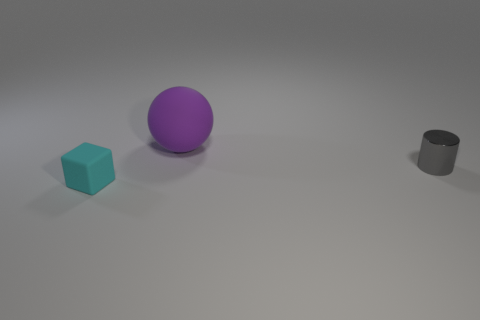Are there more tiny rubber things that are behind the rubber sphere than tiny gray shiny things to the left of the gray object? Based on the image, it is difficult to ascertain the specific materials of the objects, thus referring to them as 'rubber' may not be accurate. However, if we assess the quantities as seen, there is one blue cube behind the purple sphere, and to the left of the gray cylinder, there does not appear to be any small gray shiny objects. Therefore, it is correct to say there are not more tiny gray shiny things to the left of the gray object than tiny objects behind the purple sphere. 